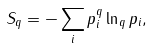Convert formula to latex. <formula><loc_0><loc_0><loc_500><loc_500>S _ { q } = - \sum _ { i } p _ { i } ^ { q } \ln _ { q } p _ { i } ,</formula> 